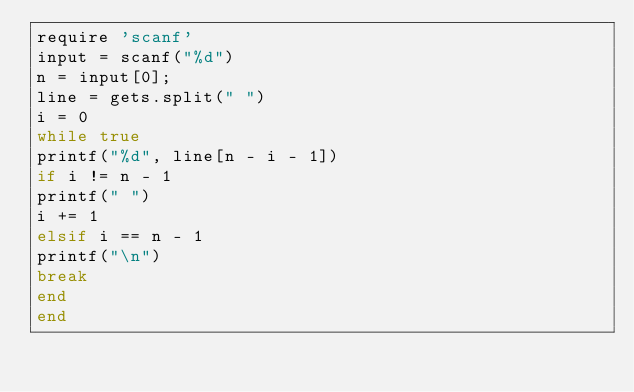<code> <loc_0><loc_0><loc_500><loc_500><_Ruby_>require 'scanf'
input = scanf("%d")
n = input[0];
line = gets.split(" ")
i = 0
while true
printf("%d", line[n - i - 1])
if i != n - 1
printf(" ")
i += 1
elsif i == n - 1
printf("\n")
break
end
end</code> 